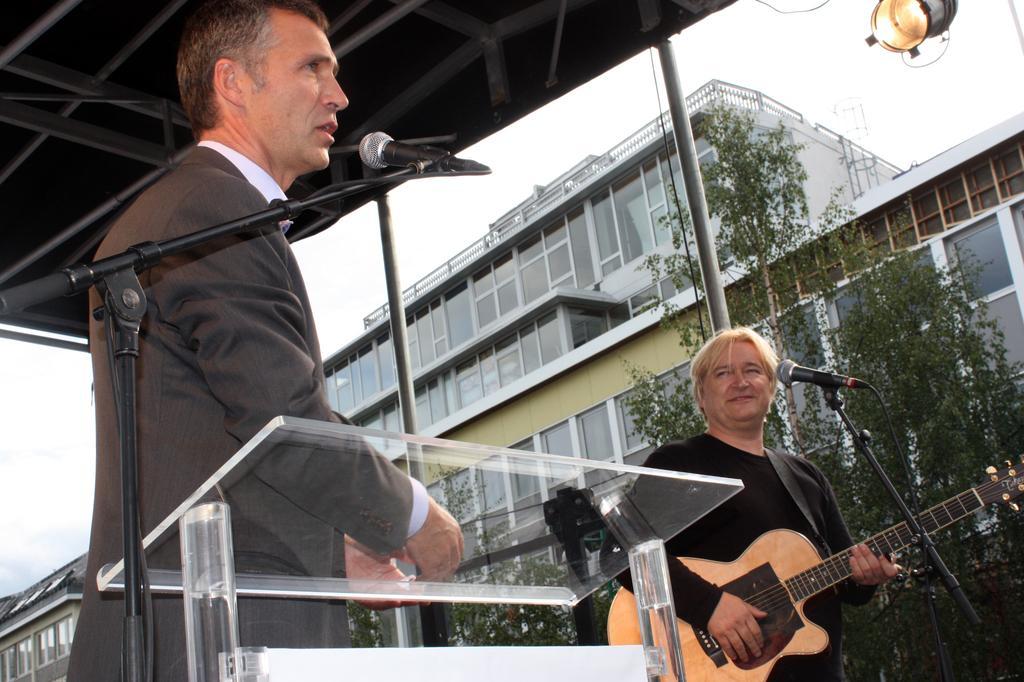In one or two sentences, can you explain what this image depicts? It is a music show a man is standing and speaking something through the mike beside him there is and other person wearing black shirt,he is playing a guitar he is also smiling there a is roof made up of iron rods to the right side in the background there is a big building and also some trees and a sky,to this roof there are some lights also. 